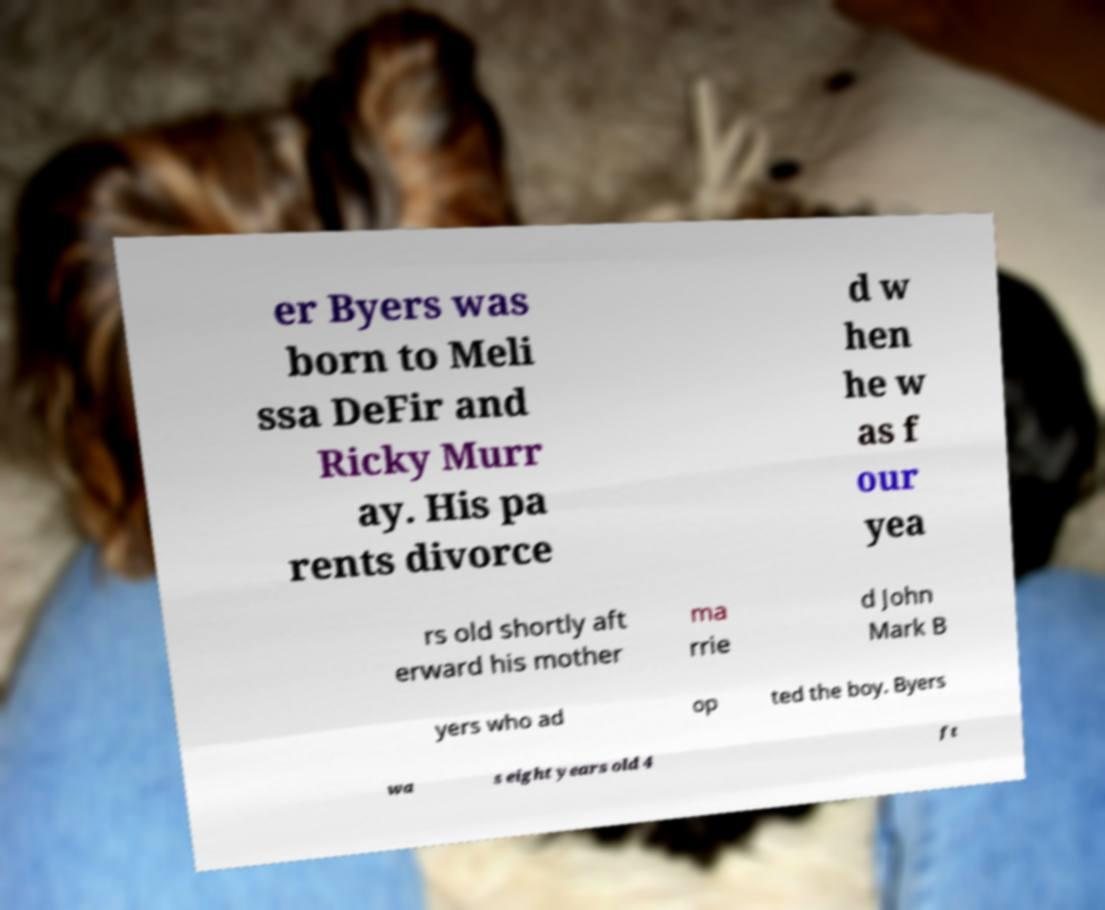Can you accurately transcribe the text from the provided image for me? er Byers was born to Meli ssa DeFir and Ricky Murr ay. His pa rents divorce d w hen he w as f our yea rs old shortly aft erward his mother ma rrie d John Mark B yers who ad op ted the boy. Byers wa s eight years old 4 ft 